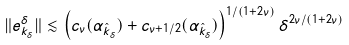<formula> <loc_0><loc_0><loc_500><loc_500>\| e _ { k _ { \delta } } ^ { \delta } \| \lesssim \left ( c _ { \nu } ( \alpha _ { \hat { k } _ { \delta } } ) + c _ { \nu + 1 / 2 } ( \alpha _ { \hat { k } _ { \delta } } ) \right ) ^ { 1 / ( 1 + 2 \nu ) } \delta ^ { 2 \nu / ( 1 + 2 \nu ) }</formula> 